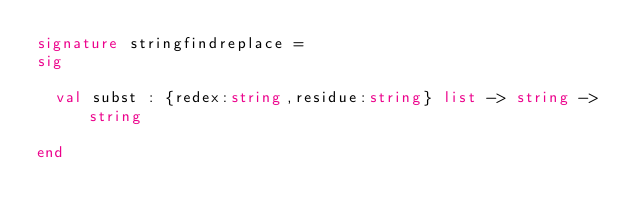<code> <loc_0><loc_0><loc_500><loc_500><_SML_>signature stringfindreplace =
sig

  val subst : {redex:string,residue:string} list -> string -> string

end
</code> 